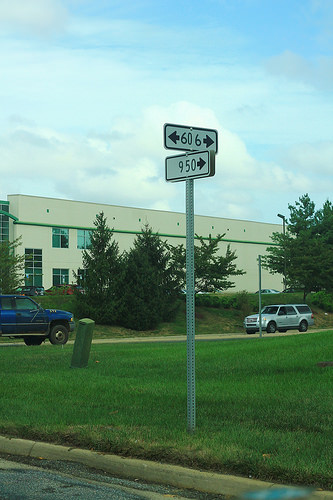<image>
Can you confirm if the vehicle is under the building? No. The vehicle is not positioned under the building. The vertical relationship between these objects is different. Is there a building behind the tree? Yes. From this viewpoint, the building is positioned behind the tree, with the tree partially or fully occluding the building. 